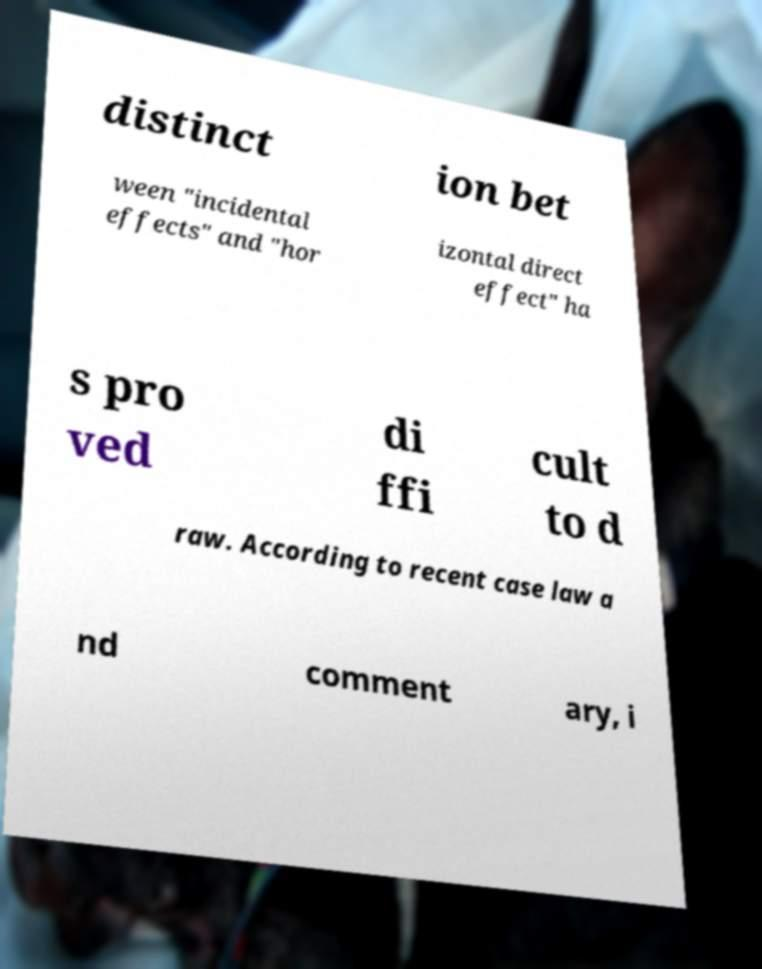Can you read and provide the text displayed in the image?This photo seems to have some interesting text. Can you extract and type it out for me? distinct ion bet ween "incidental effects" and "hor izontal direct effect" ha s pro ved di ffi cult to d raw. According to recent case law a nd comment ary, i 